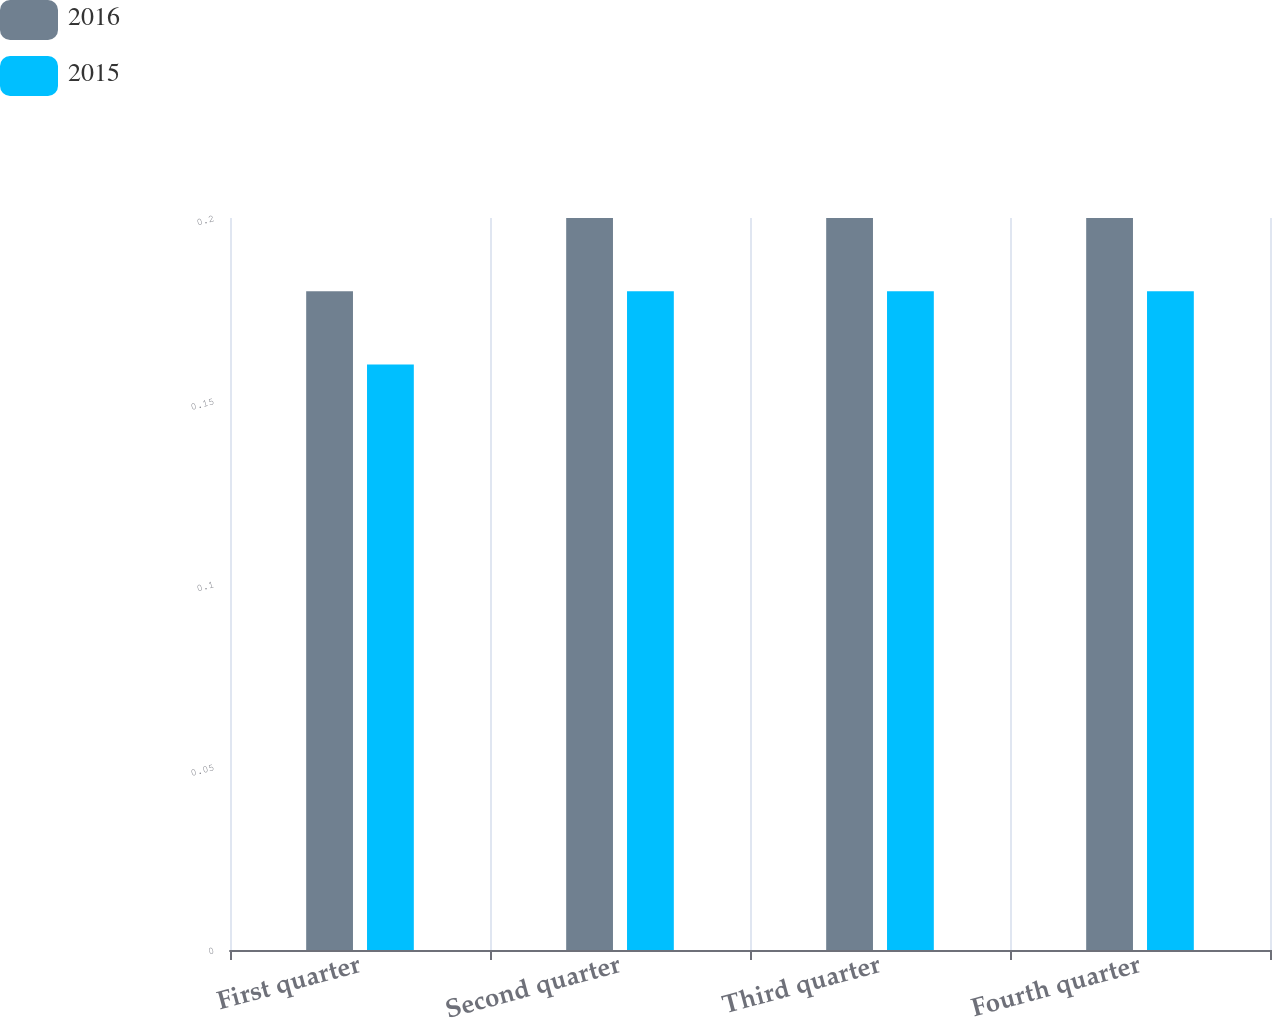<chart> <loc_0><loc_0><loc_500><loc_500><stacked_bar_chart><ecel><fcel>First quarter<fcel>Second quarter<fcel>Third quarter<fcel>Fourth quarter<nl><fcel>2016<fcel>0.18<fcel>0.2<fcel>0.2<fcel>0.2<nl><fcel>2015<fcel>0.16<fcel>0.18<fcel>0.18<fcel>0.18<nl></chart> 